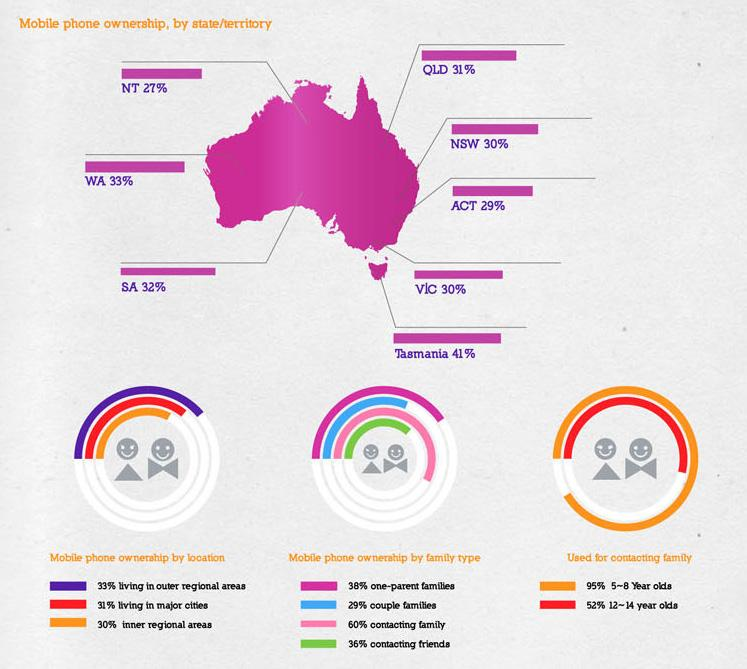Highlight a few significant elements in this photo. According to data, the mobile ownership rate in Western Australia is 33%. According to a recent survey, 52% of children aged 12-14 in Australia use mobile phones to stay in touch with their families. In Australia, the ownership of mobile phones among couples is reported to be 29%. According to the data, Tasmania has the highest mobile ownership rate among all states in Australia. According to a survey conducted in Australia, 95% of children aged 5-8 years old use mobile phones to contact their families. 